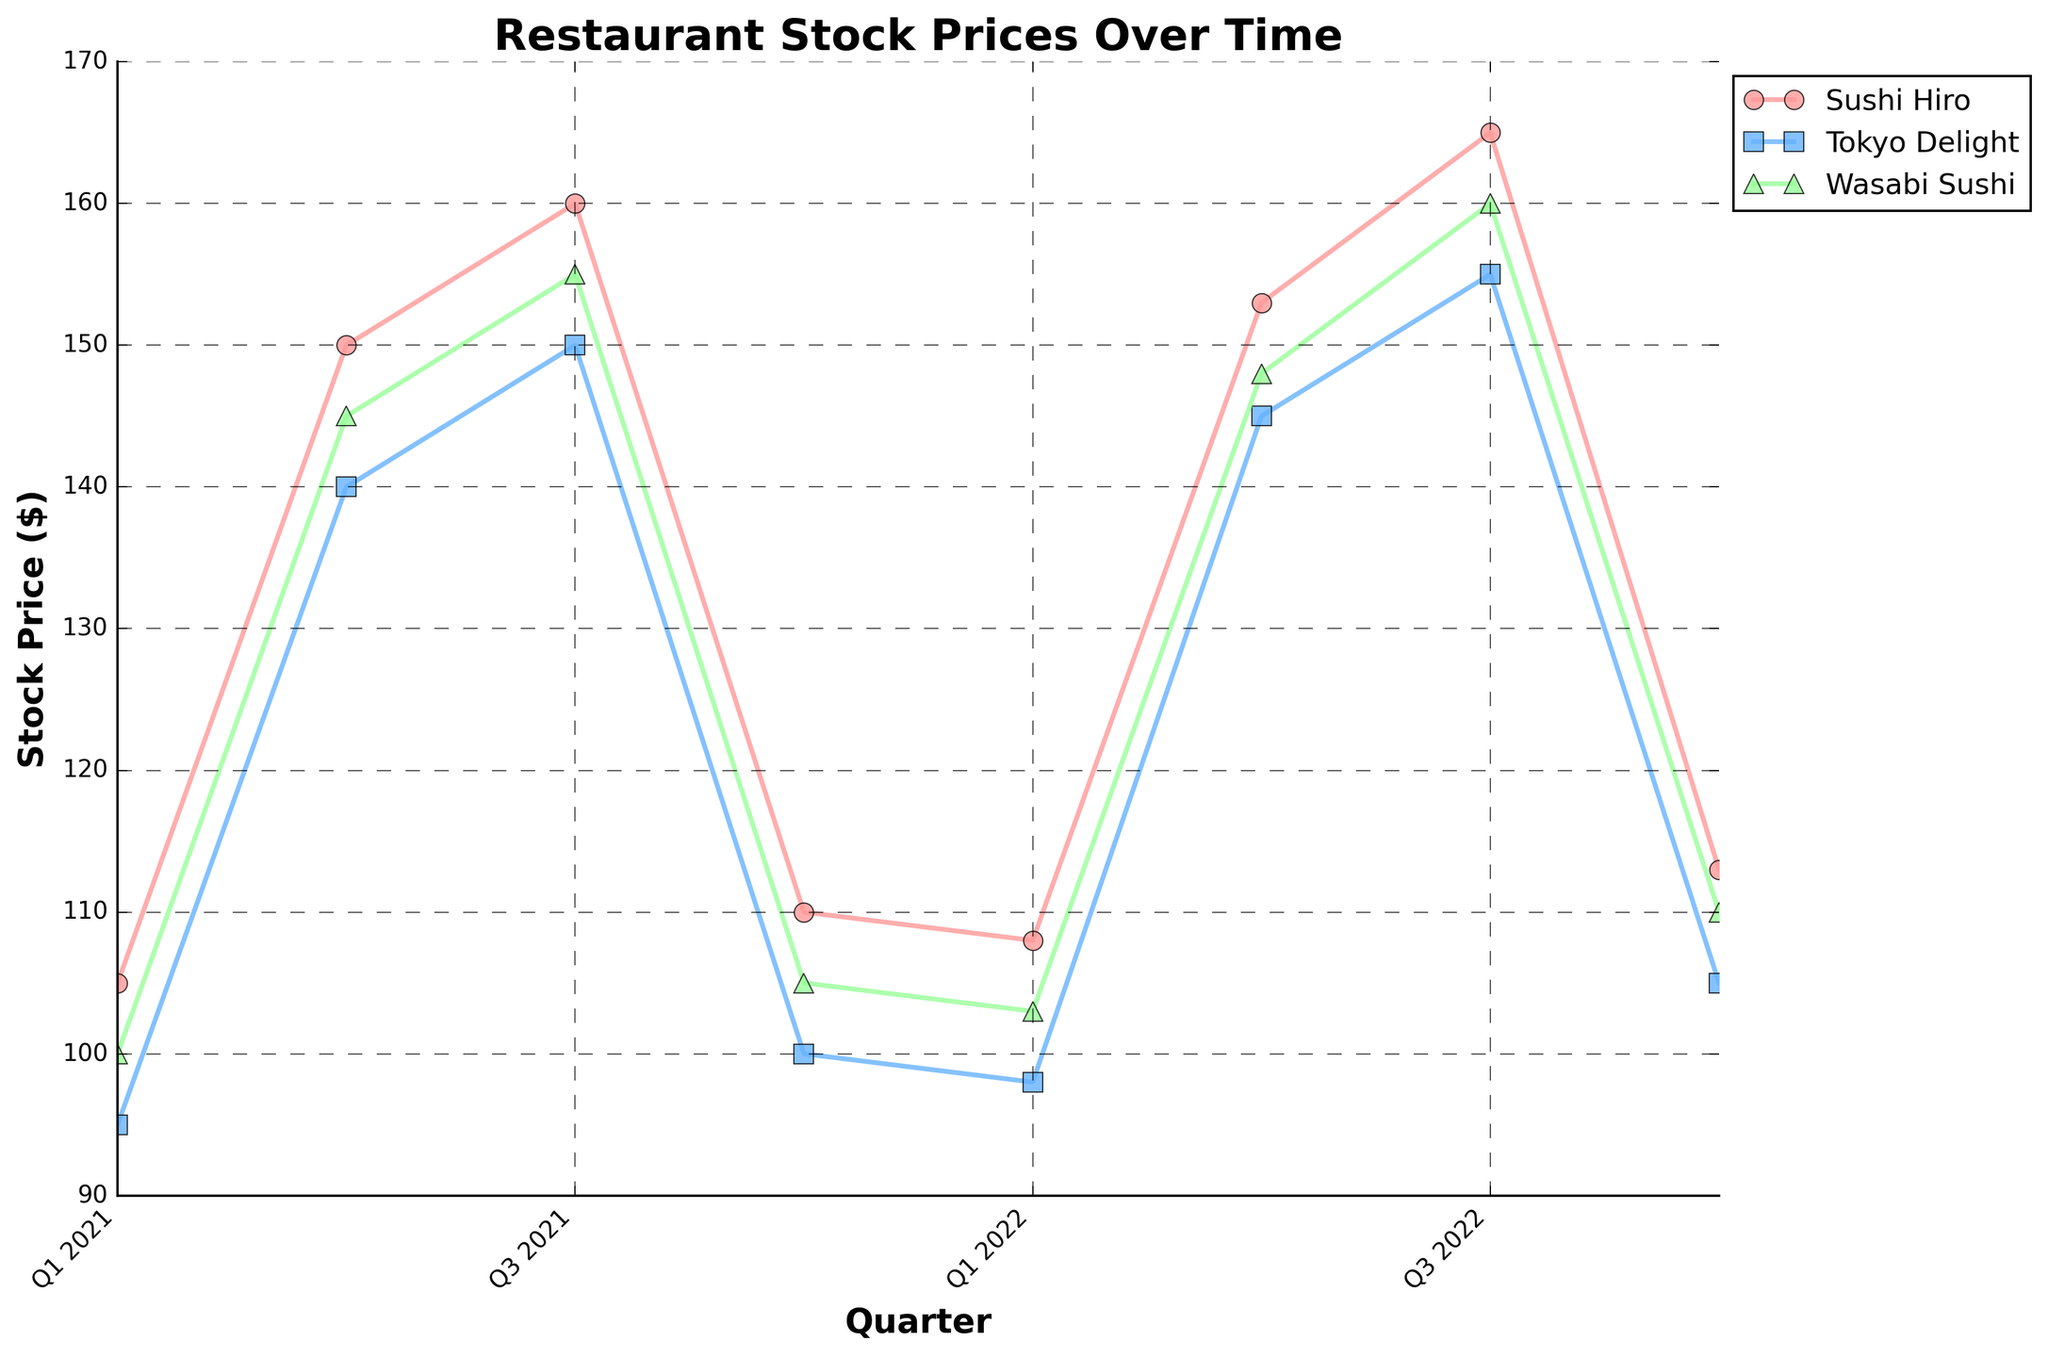What's the title of the figure? The title of a figure is typically displayed at the top. In this case, the title is "Restaurant Stock Prices Over Time", as described in the plot generation code.
Answer: Restaurant Stock Prices Over Time What are the x and y-axis labels? The x-axis label is typically along the horizontal axis, and the y-axis label is along the vertical axis. In the plot, the x-axis is labeled "Quarter" and the y-axis is labeled "Stock Price ($)".
Answer: Quarter, Stock Price ($) Which restaurant had the highest stock price in Q3 2021? Look at the data points for Q3 2021 and compare the stock prices of the three restaurants. Sushi Hiro had a stock price of 160, Tokyo Delight had 150, and Wasabi Sushi had 155. Sushi Hiro's stock price is the highest.
Answer: Sushi Hiro What is the overall trend in stock prices from Q1 2021 to Q4 2022? Assess the stock price progression for all restaurants over the quarters. Despite some fluctuations, there is a general upward trend from Q1 2021 to Q3 2022 and then a drop in Q4 2022.
Answer: Upward trend, then drop How does the stock price vary between Q2 and Q4 2021 for Tokyo Delight? Look at the stock prices for Tokyo Delight between Q2 (140), Q3 (150), and Q4 (100) in 2021. There is an increase from Q2 to Q3 and a subsequent decrease from Q3 to Q4.
Answer: Increase then decrease Which restaurant shows the most significant growth in stock price between Q1 2021 and Q2 2021? Compare the change in stock prices from Q1 2021 to Q2 2021 for all restaurants. Sushi Hiro's stock price increased from 105 to 150, Tokyo Delight from 95 to 140, and Wasabi Sushi from 100 to 145. Sushi Hiro shows the most significant growth (45).
Answer: Sushi Hiro On average, which quarter shows the highest stock prices among all restaurants? Calculate the average of stock prices for all restaurants for each quarter. Q3 2022 has stock prices of 165, 155, and 160, averaging (165+155+160)/3 = 160. Q3 2022 shows the highest average stock price.
Answer: Q3 2022 What pattern do you notice about stock prices in Q3 across all years? Examine the stock prices in Q3 of both years (2021, 2022). The prices are relatively higher in Q3 for both years, indicating a pattern of peak stock prices during this quarter.
Answer: Higher in Q3 How does the stock price of Wasabi Sushi in Q1 2022 compare to Q4 2022? Look at the stock prices of Wasabi Sushi in Q1 2022 (103) and Q4 2022 (110). The stock price increased by 7 from Q1 2022 to Q4 2022.
Answer: Increased by 7 Based on the data, which quarter consistently shows a drop in stock prices for all restaurants? Observe the stock prices across all quarters. Q4 of both 2021 and 2022 consistently shows a drop in stock prices for Sushi Hiro, Tokyo Delight, and Wasabi Sushi.
Answer: Q4 